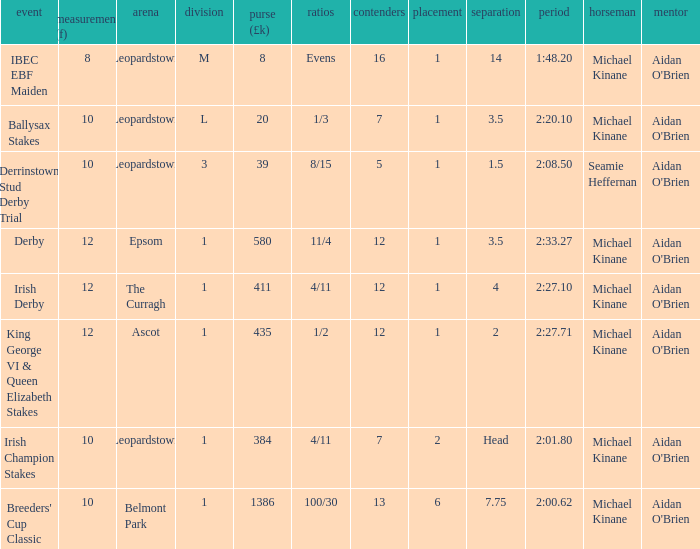Which Race has a Runners of 7 and Odds of 1/3? Ballysax Stakes. 